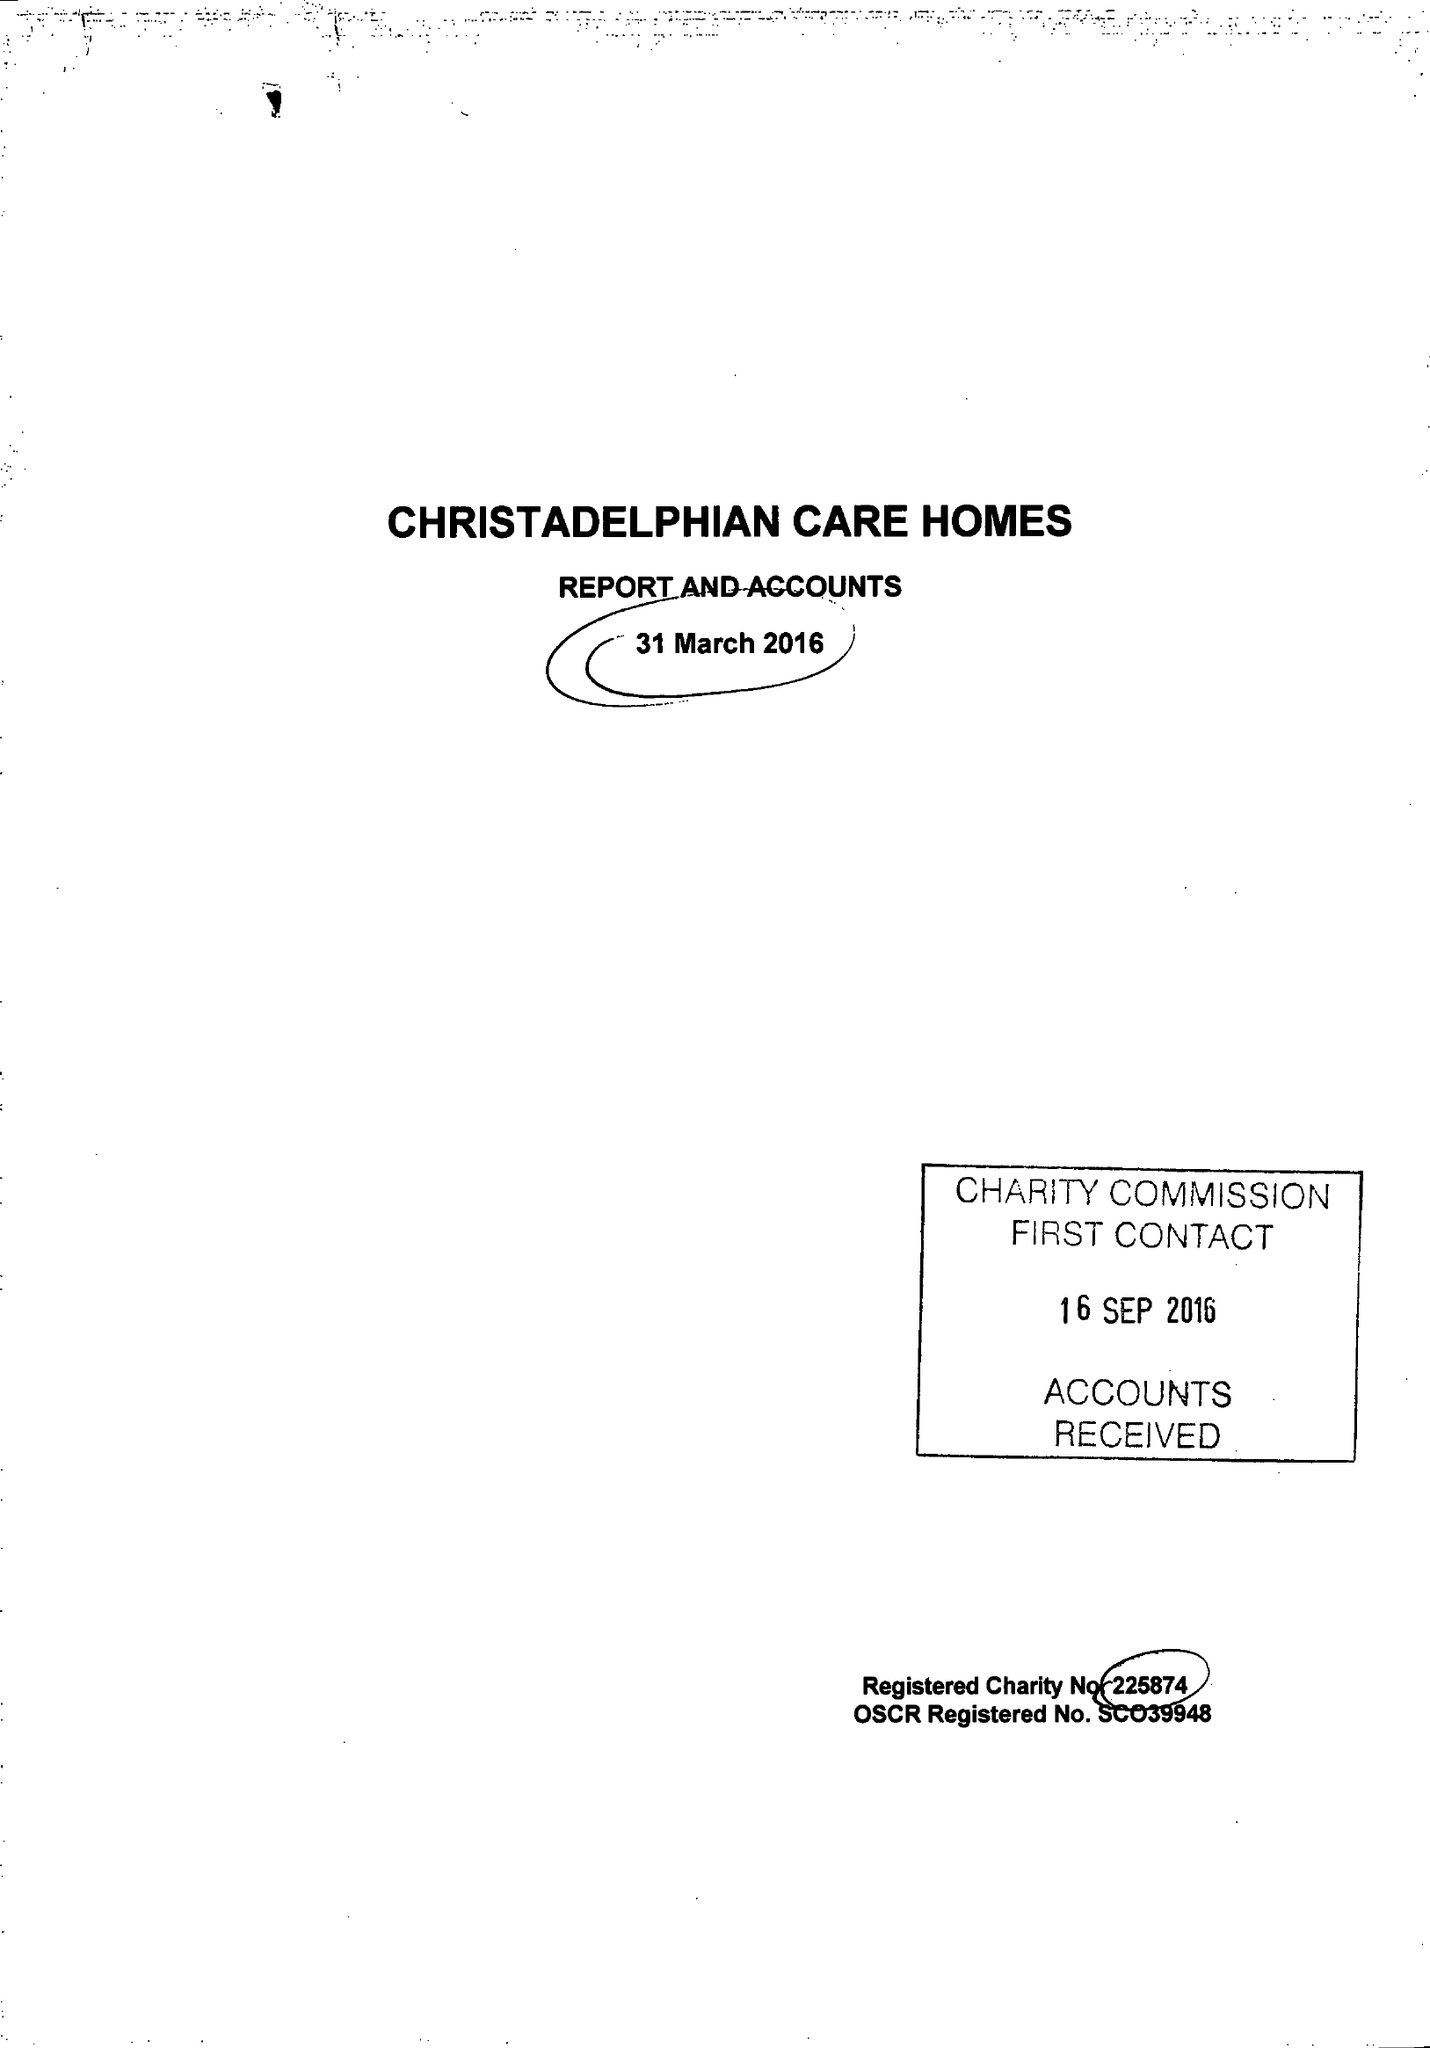What is the value for the charity_number?
Answer the question using a single word or phrase. 225874 